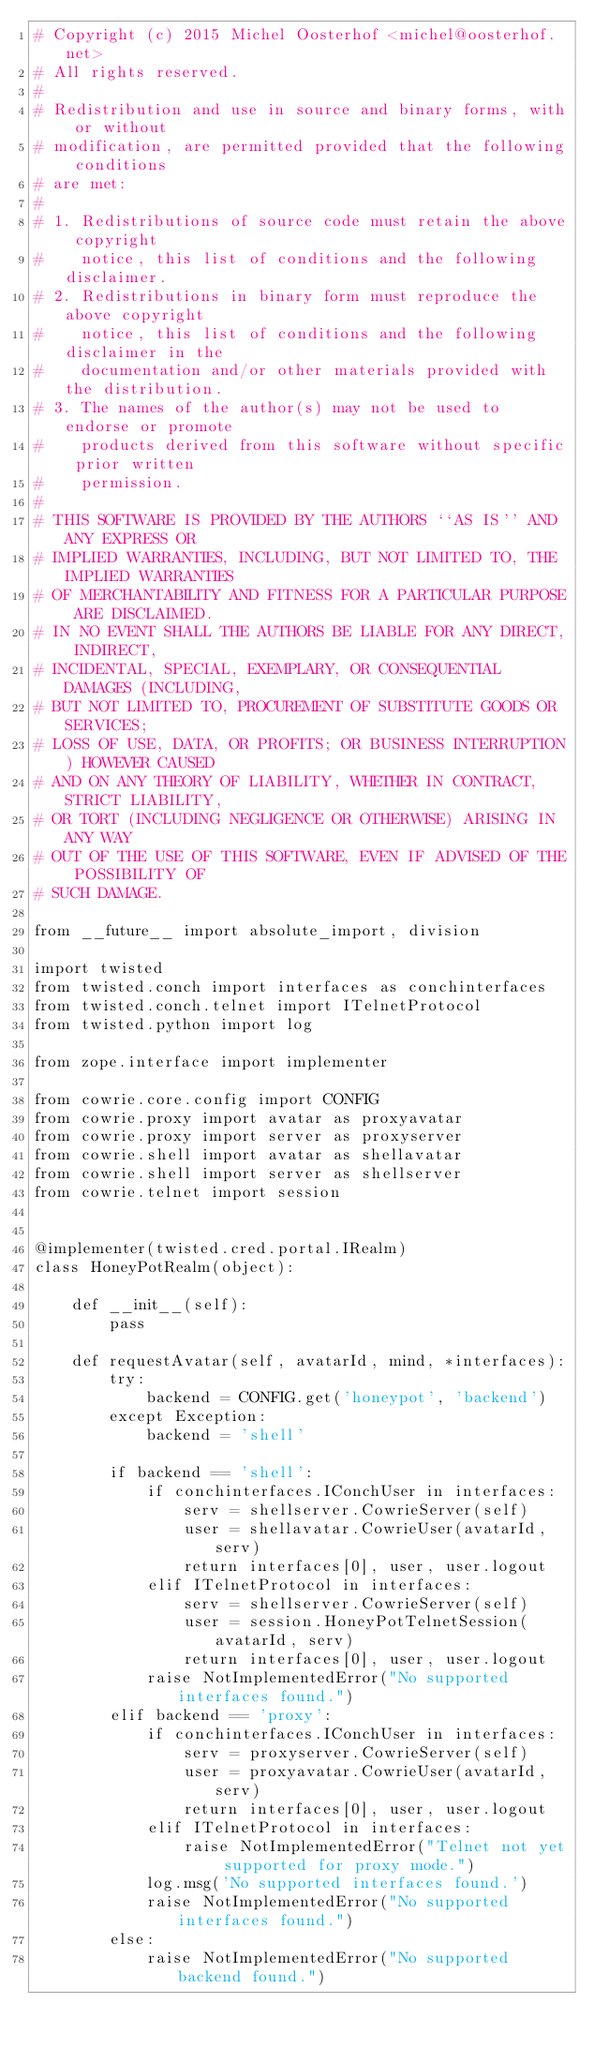<code> <loc_0><loc_0><loc_500><loc_500><_Python_># Copyright (c) 2015 Michel Oosterhof <michel@oosterhof.net>
# All rights reserved.
#
# Redistribution and use in source and binary forms, with or without
# modification, are permitted provided that the following conditions
# are met:
#
# 1. Redistributions of source code must retain the above copyright
#    notice, this list of conditions and the following disclaimer.
# 2. Redistributions in binary form must reproduce the above copyright
#    notice, this list of conditions and the following disclaimer in the
#    documentation and/or other materials provided with the distribution.
# 3. The names of the author(s) may not be used to endorse or promote
#    products derived from this software without specific prior written
#    permission.
#
# THIS SOFTWARE IS PROVIDED BY THE AUTHORS ``AS IS'' AND ANY EXPRESS OR
# IMPLIED WARRANTIES, INCLUDING, BUT NOT LIMITED TO, THE IMPLIED WARRANTIES
# OF MERCHANTABILITY AND FITNESS FOR A PARTICULAR PURPOSE ARE DISCLAIMED.
# IN NO EVENT SHALL THE AUTHORS BE LIABLE FOR ANY DIRECT, INDIRECT,
# INCIDENTAL, SPECIAL, EXEMPLARY, OR CONSEQUENTIAL DAMAGES (INCLUDING,
# BUT NOT LIMITED TO, PROCUREMENT OF SUBSTITUTE GOODS OR SERVICES;
# LOSS OF USE, DATA, OR PROFITS; OR BUSINESS INTERRUPTION) HOWEVER CAUSED
# AND ON ANY THEORY OF LIABILITY, WHETHER IN CONTRACT, STRICT LIABILITY,
# OR TORT (INCLUDING NEGLIGENCE OR OTHERWISE) ARISING IN ANY WAY
# OUT OF THE USE OF THIS SOFTWARE, EVEN IF ADVISED OF THE POSSIBILITY OF
# SUCH DAMAGE.

from __future__ import absolute_import, division

import twisted
from twisted.conch import interfaces as conchinterfaces
from twisted.conch.telnet import ITelnetProtocol
from twisted.python import log

from zope.interface import implementer

from cowrie.core.config import CONFIG
from cowrie.proxy import avatar as proxyavatar
from cowrie.proxy import server as proxyserver
from cowrie.shell import avatar as shellavatar
from cowrie.shell import server as shellserver
from cowrie.telnet import session


@implementer(twisted.cred.portal.IRealm)
class HoneyPotRealm(object):

    def __init__(self):
        pass

    def requestAvatar(self, avatarId, mind, *interfaces):
        try:
            backend = CONFIG.get('honeypot', 'backend')
        except Exception:
            backend = 'shell'

        if backend == 'shell':
            if conchinterfaces.IConchUser in interfaces:
                serv = shellserver.CowrieServer(self)
                user = shellavatar.CowrieUser(avatarId, serv)
                return interfaces[0], user, user.logout
            elif ITelnetProtocol in interfaces:
                serv = shellserver.CowrieServer(self)
                user = session.HoneyPotTelnetSession(avatarId, serv)
                return interfaces[0], user, user.logout
            raise NotImplementedError("No supported interfaces found.")
        elif backend == 'proxy':
            if conchinterfaces.IConchUser in interfaces:
                serv = proxyserver.CowrieServer(self)
                user = proxyavatar.CowrieUser(avatarId, serv)
                return interfaces[0], user, user.logout
            elif ITelnetProtocol in interfaces:
                raise NotImplementedError("Telnet not yet supported for proxy mode.")
            log.msg('No supported interfaces found.')
            raise NotImplementedError("No supported interfaces found.")
        else:
            raise NotImplementedError("No supported backend found.")
</code> 